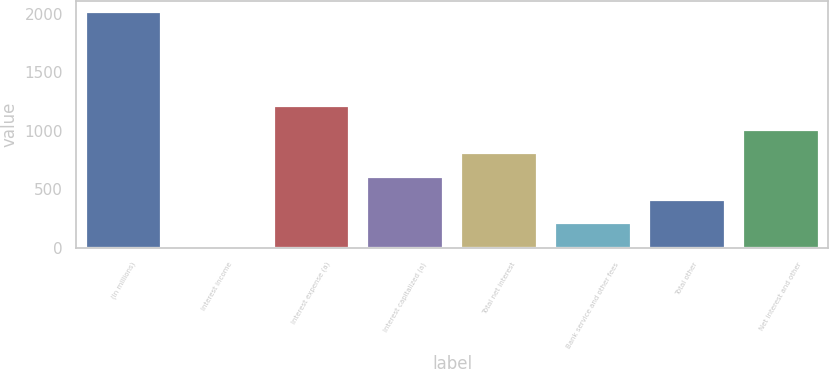Convert chart to OTSL. <chart><loc_0><loc_0><loc_500><loc_500><bar_chart><fcel>(In millions)<fcel>Interest income<fcel>Interest expense (a)<fcel>Interest capitalized (a)<fcel>Total net interest<fcel>Bank service and other fees<fcel>Total other<fcel>Net interest and other<nl><fcel>2013<fcel>9<fcel>1211.4<fcel>610.2<fcel>810.6<fcel>209.4<fcel>409.8<fcel>1011<nl></chart> 